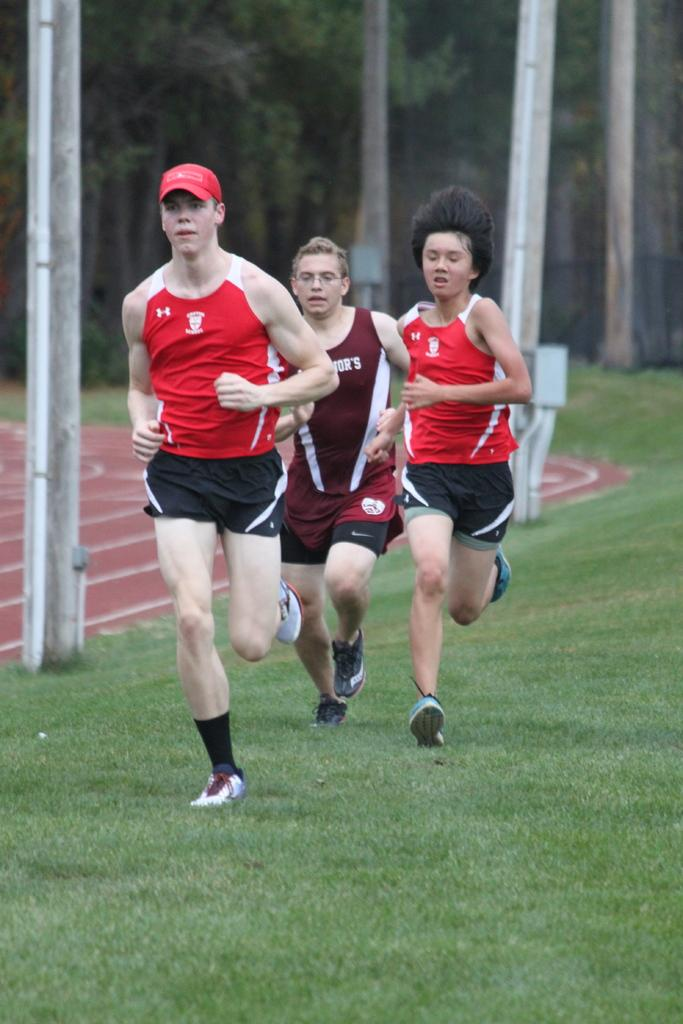What are the people in the image doing? The people in the image are running. On what surface are the people running? The people are running on the grass. What can be seen in the background of the image? There are trees and the ground visible in the background of the image. What objects are present in the image besides the people? There are poles in the image. What type of waves can be seen crashing on the shore in the image? There are no waves or shore present in the image; it features people running on grass with trees and poles in the background. 